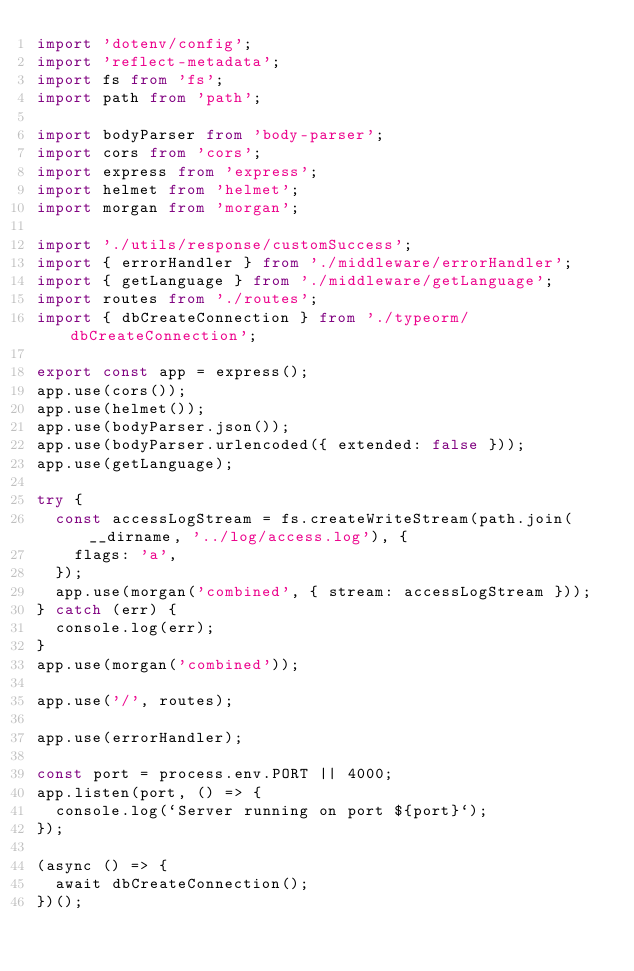<code> <loc_0><loc_0><loc_500><loc_500><_TypeScript_>import 'dotenv/config';
import 'reflect-metadata';
import fs from 'fs';
import path from 'path';

import bodyParser from 'body-parser';
import cors from 'cors';
import express from 'express';
import helmet from 'helmet';
import morgan from 'morgan';

import './utils/response/customSuccess';
import { errorHandler } from './middleware/errorHandler';
import { getLanguage } from './middleware/getLanguage';
import routes from './routes';
import { dbCreateConnection } from './typeorm/dbCreateConnection';

export const app = express();
app.use(cors());
app.use(helmet());
app.use(bodyParser.json());
app.use(bodyParser.urlencoded({ extended: false }));
app.use(getLanguage);

try {
  const accessLogStream = fs.createWriteStream(path.join(__dirname, '../log/access.log'), {
    flags: 'a',
  });
  app.use(morgan('combined', { stream: accessLogStream }));
} catch (err) {
  console.log(err);
}
app.use(morgan('combined'));

app.use('/', routes);

app.use(errorHandler);

const port = process.env.PORT || 4000;
app.listen(port, () => {
  console.log(`Server running on port ${port}`);
});

(async () => {
  await dbCreateConnection();
})();
</code> 